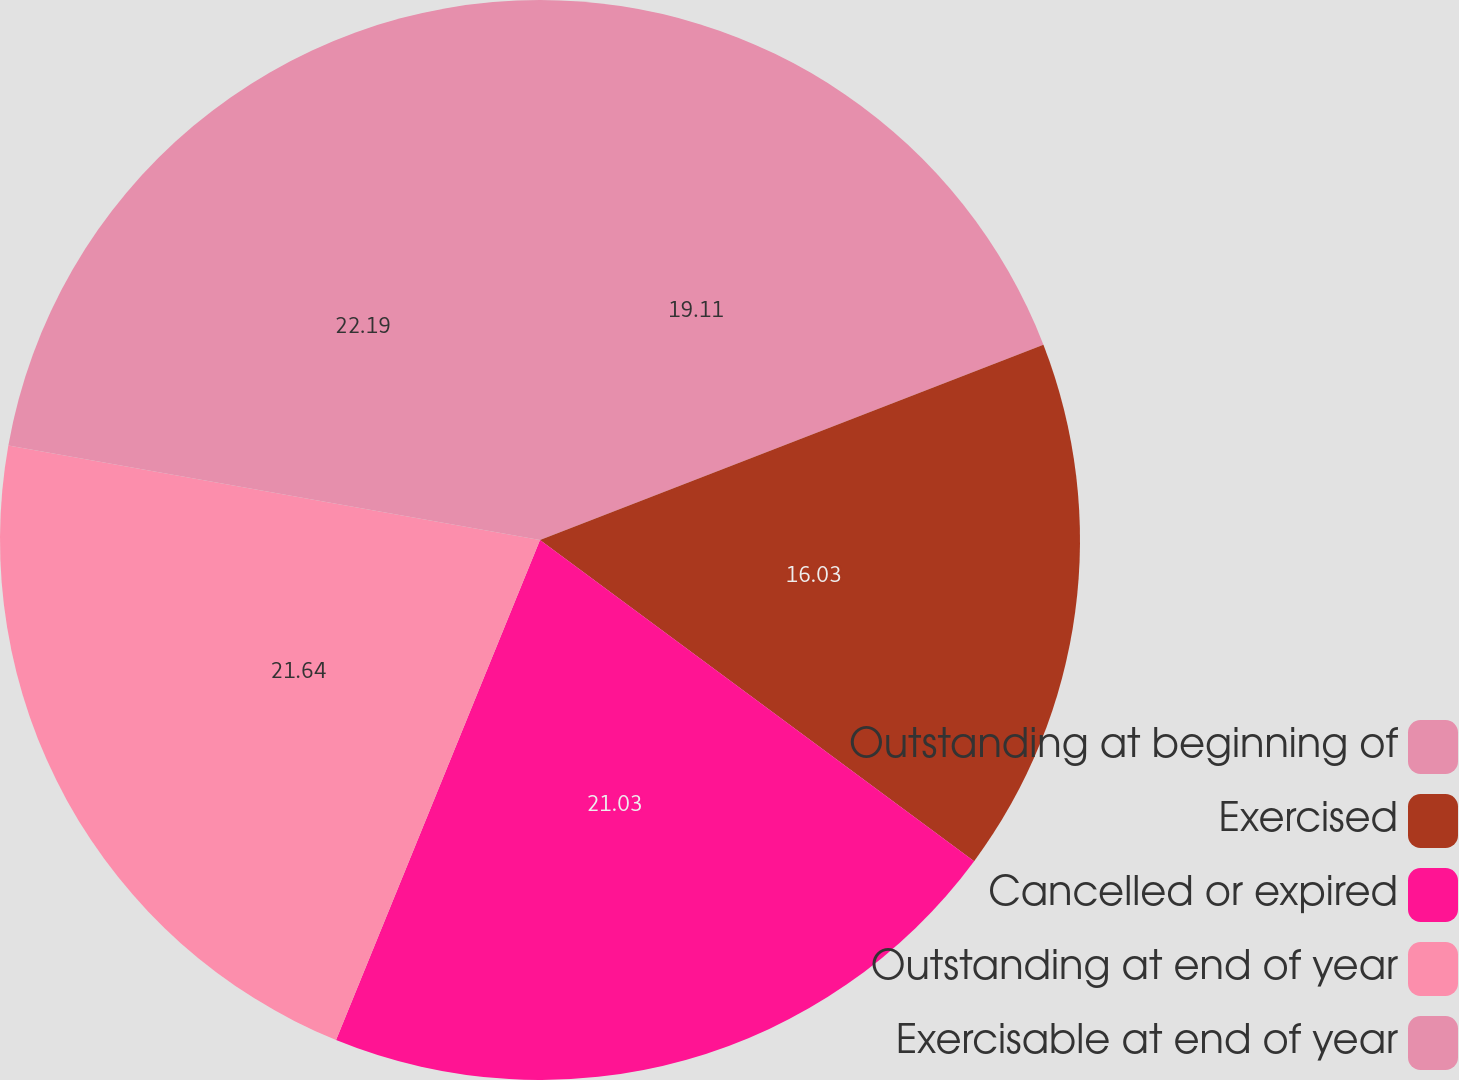<chart> <loc_0><loc_0><loc_500><loc_500><pie_chart><fcel>Outstanding at beginning of<fcel>Exercised<fcel>Cancelled or expired<fcel>Outstanding at end of year<fcel>Exercisable at end of year<nl><fcel>19.11%<fcel>16.03%<fcel>21.03%<fcel>21.64%<fcel>22.2%<nl></chart> 